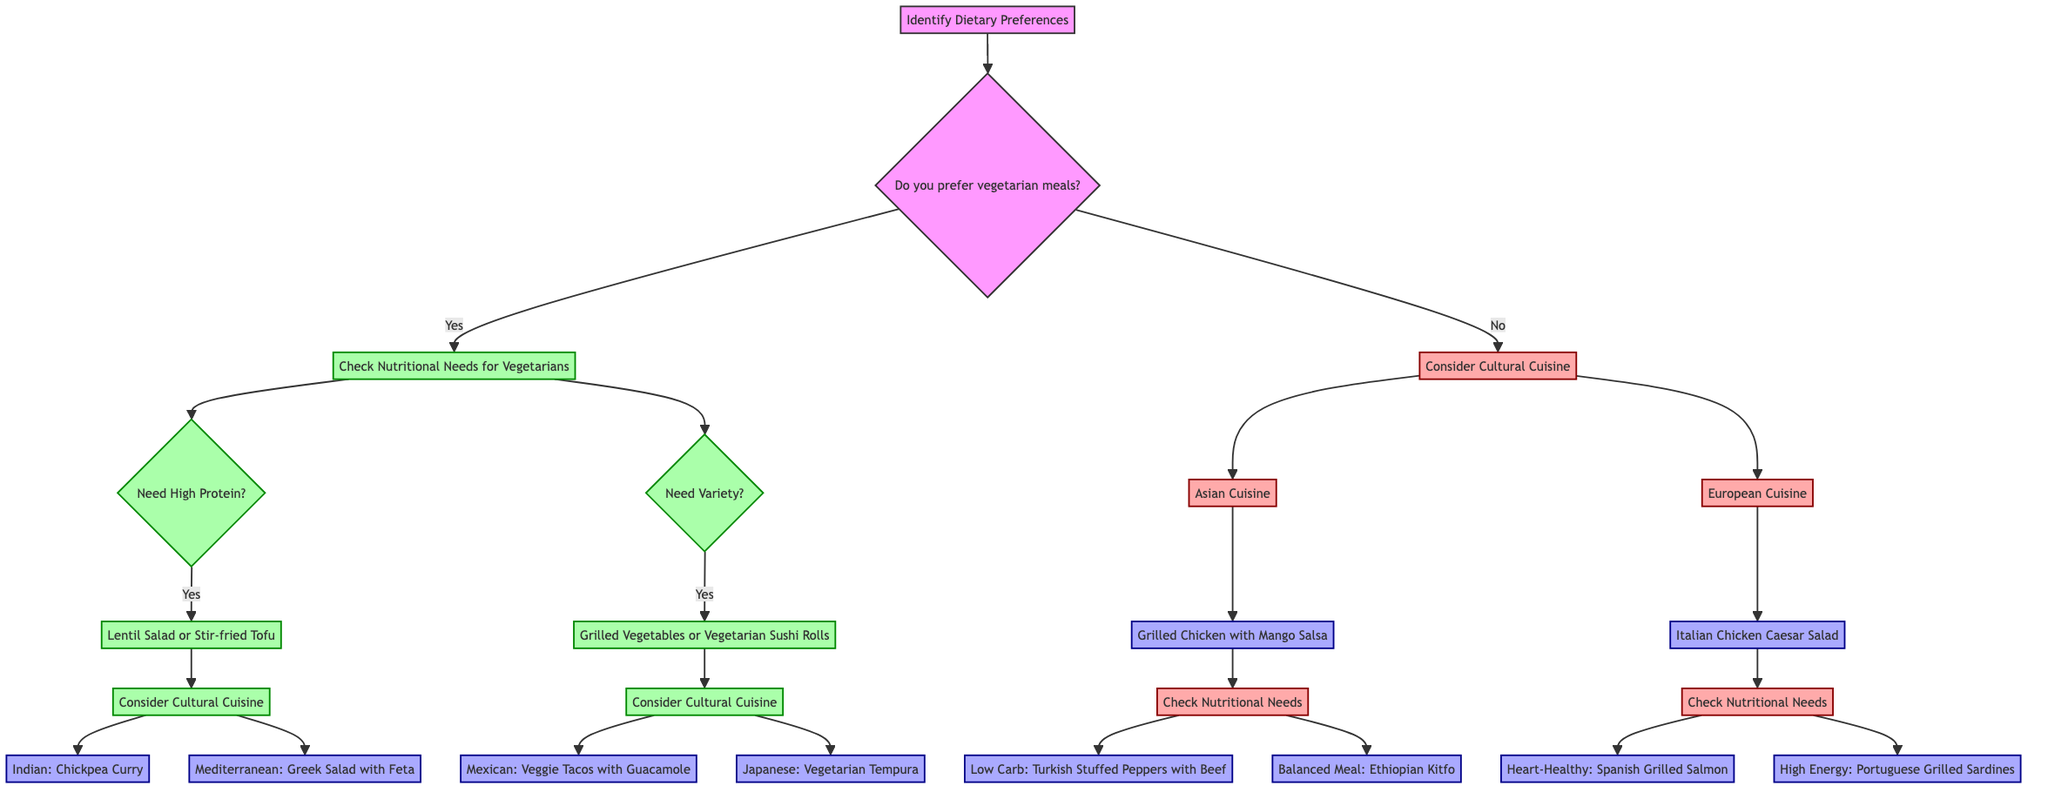What is the first question in the diagram? The diagram begins with asking about dietary preferences: "Do you prefer vegetarian meals?"
Answer: Do you prefer vegetarian meals? How many options are there for high-protein vegetarian meals? The high-protein vegetarian meal options indicated in the diagram are Lentil Salad and Stir-fried Tofu, which totals to two options.
Answer: 2 What meal is suggested for low-carb nutritional needs? The diagram states that for low-carb needs, one should choose "Turkish Stuffed Peppers with Beef."
Answer: Turkish Stuffed Peppers with Beef If someone prefers vegetarian meals and needs variety, which cuisine options are provided? For those who prefer vegetarian and need variety, the diagram suggests considering cultural cuisines: Mexican Cuisine (Veggie Tacos with Guacamole) and Japanese Cuisine (Vegetarian Tempura), totaling two meal options.
Answer: 2 What are the two choices under the non-vegetarian Asian cuisine section? In the non-vegetarian Asian cuisine section, the options are "Grilled Chicken with Mango Salsa" followed by the nutritional needs: "Low Carb: Turkish Stuffed Peppers with Beef" and "Balanced Meal: Ethiopian Kitfo."
Answer: Grilled Chicken with Mango Salsa and Ethiopian Kitfo What nutritional needs does the diagram check for non-vegetarian meals following European cuisine? After the European cuisine section, the diagram checks low-carb needs and high-energy needs for non-vegetarian meals, suggesting Spanish Grilled Salmon and Portuguese Grilled Sardines respectively.
Answer: Low-carb and high-energy Which vegetarian meal option is associated with Indian cuisine? The diagram indicates that the vegetarian meal option associated with Indian cuisine is "Chickpea Curry (Chana Masala)."
Answer: Chickpea Curry (Chana Masala) What is the last node in the tree for non-vegetarian meals? The last node in the tree for non-vegetarian meals is "High Energy: Portuguese Grilled Sardines," which is connected to the Italian Chicken Caesar Salad option.
Answer: High Energy: Portuguese Grilled Sardines 